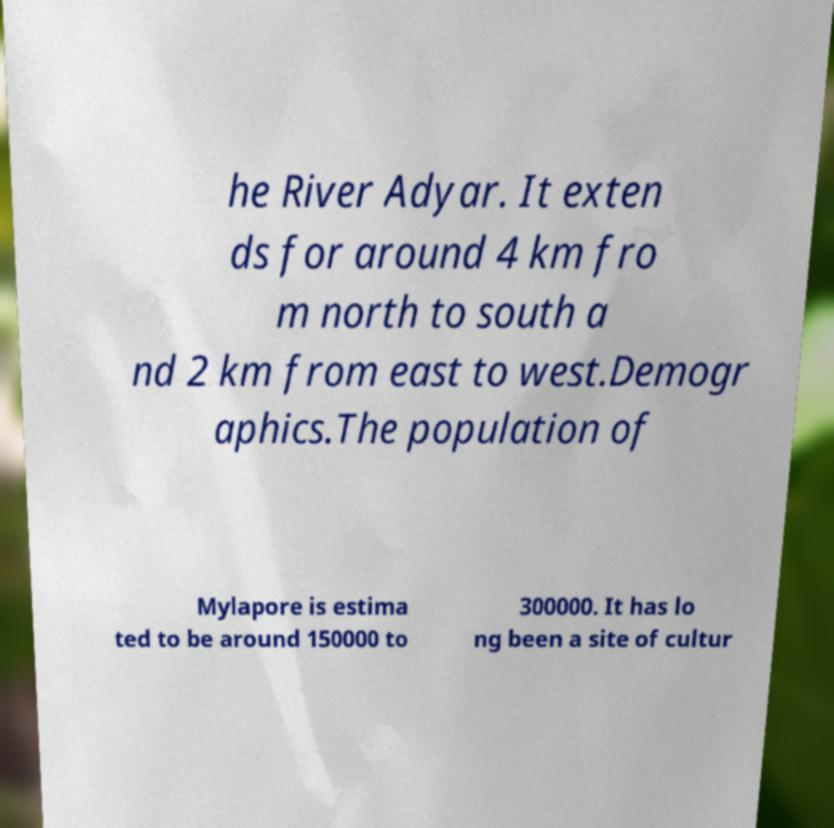I need the written content from this picture converted into text. Can you do that? he River Adyar. It exten ds for around 4 km fro m north to south a nd 2 km from east to west.Demogr aphics.The population of Mylapore is estima ted to be around 150000 to 300000. It has lo ng been a site of cultur 